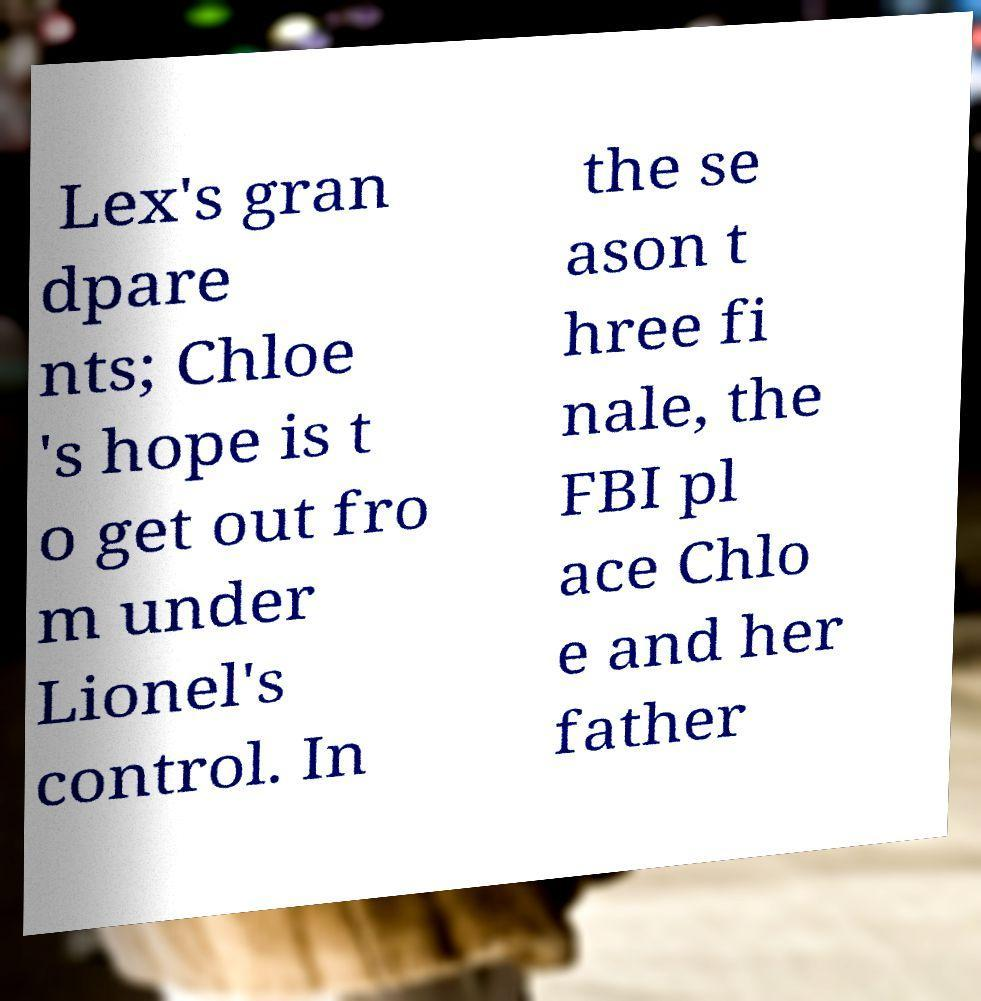Can you read and provide the text displayed in the image?This photo seems to have some interesting text. Can you extract and type it out for me? Lex's gran dpare nts; Chloe 's hope is t o get out fro m under Lionel's control. In the se ason t hree fi nale, the FBI pl ace Chlo e and her father 